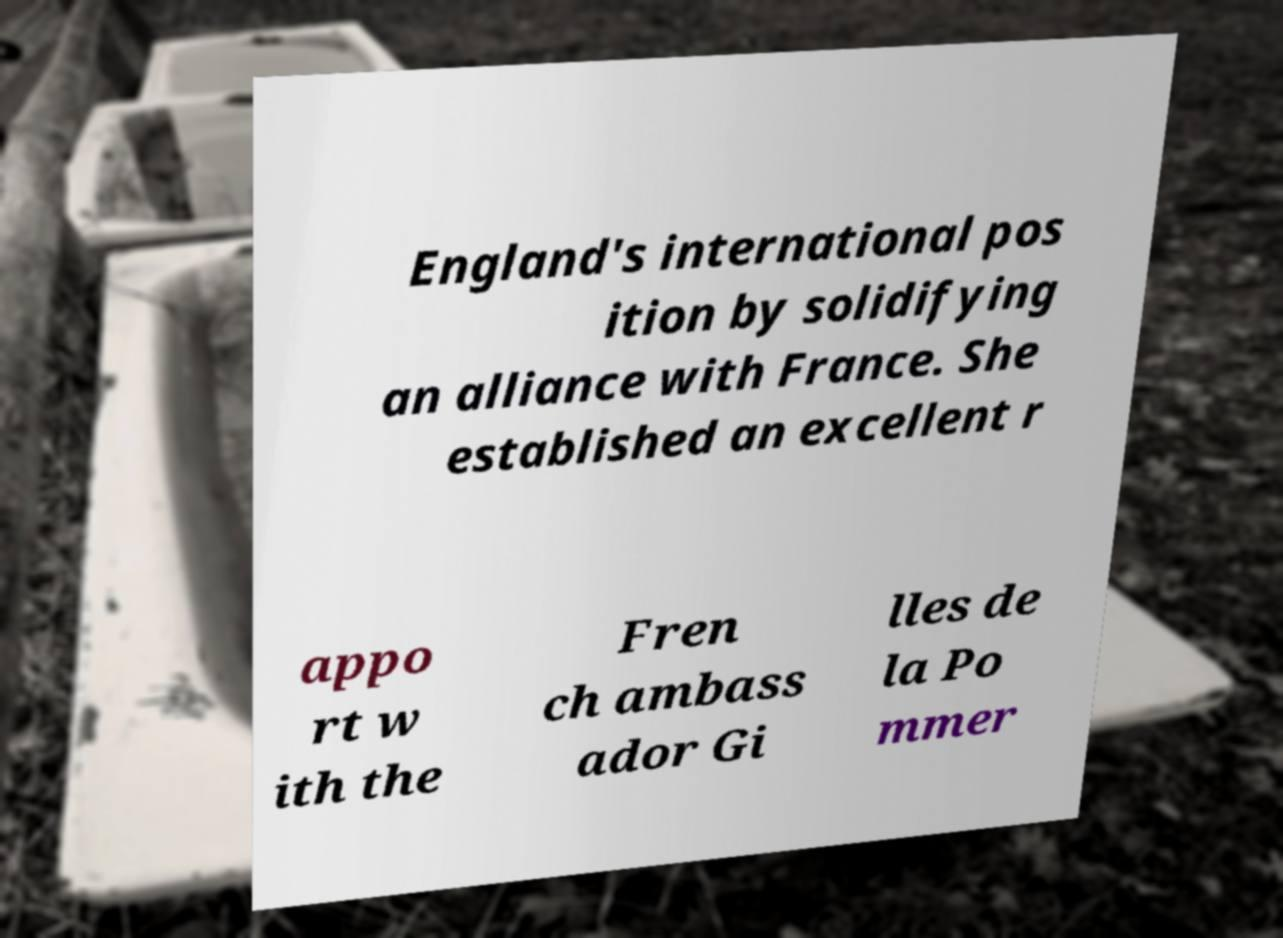There's text embedded in this image that I need extracted. Can you transcribe it verbatim? England's international pos ition by solidifying an alliance with France. She established an excellent r appo rt w ith the Fren ch ambass ador Gi lles de la Po mmer 